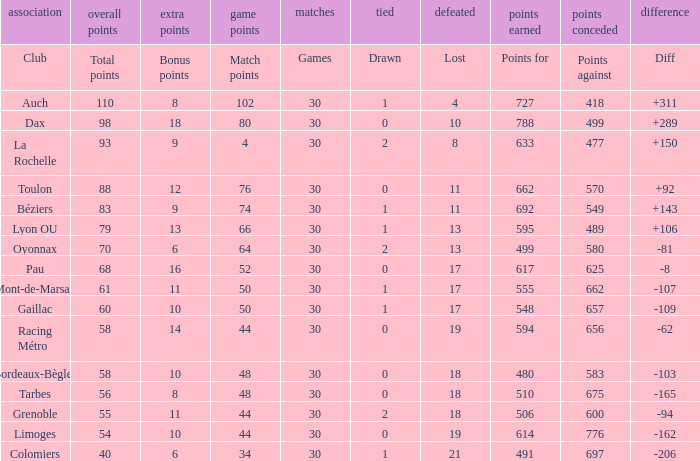How many bonus points did the Colomiers earn? 6.0. Would you be able to parse every entry in this table? {'header': ['association', 'overall points', 'extra points', 'game points', 'matches', 'tied', 'defeated', 'points earned', 'points conceded', 'difference'], 'rows': [['Club', 'Total points', 'Bonus points', 'Match points', 'Games', 'Drawn', 'Lost', 'Points for', 'Points against', 'Diff'], ['Auch', '110', '8', '102', '30', '1', '4', '727', '418', '+311'], ['Dax', '98', '18', '80', '30', '0', '10', '788', '499', '+289'], ['La Rochelle', '93', '9', '4', '30', '2', '8', '633', '477', '+150'], ['Toulon', '88', '12', '76', '30', '0', '11', '662', '570', '+92'], ['Béziers', '83', '9', '74', '30', '1', '11', '692', '549', '+143'], ['Lyon OU', '79', '13', '66', '30', '1', '13', '595', '489', '+106'], ['Oyonnax', '70', '6', '64', '30', '2', '13', '499', '580', '-81'], ['Pau', '68', '16', '52', '30', '0', '17', '617', '625', '-8'], ['Mont-de-Marsan', '61', '11', '50', '30', '1', '17', '555', '662', '-107'], ['Gaillac', '60', '10', '50', '30', '1', '17', '548', '657', '-109'], ['Racing Métro', '58', '14', '44', '30', '0', '19', '594', '656', '-62'], ['Bordeaux-Bègles', '58', '10', '48', '30', '0', '18', '480', '583', '-103'], ['Tarbes', '56', '8', '48', '30', '0', '18', '510', '675', '-165'], ['Grenoble', '55', '11', '44', '30', '2', '18', '506', '600', '-94'], ['Limoges', '54', '10', '44', '30', '0', '19', '614', '776', '-162'], ['Colomiers', '40', '6', '34', '30', '1', '21', '491', '697', '-206']]} 